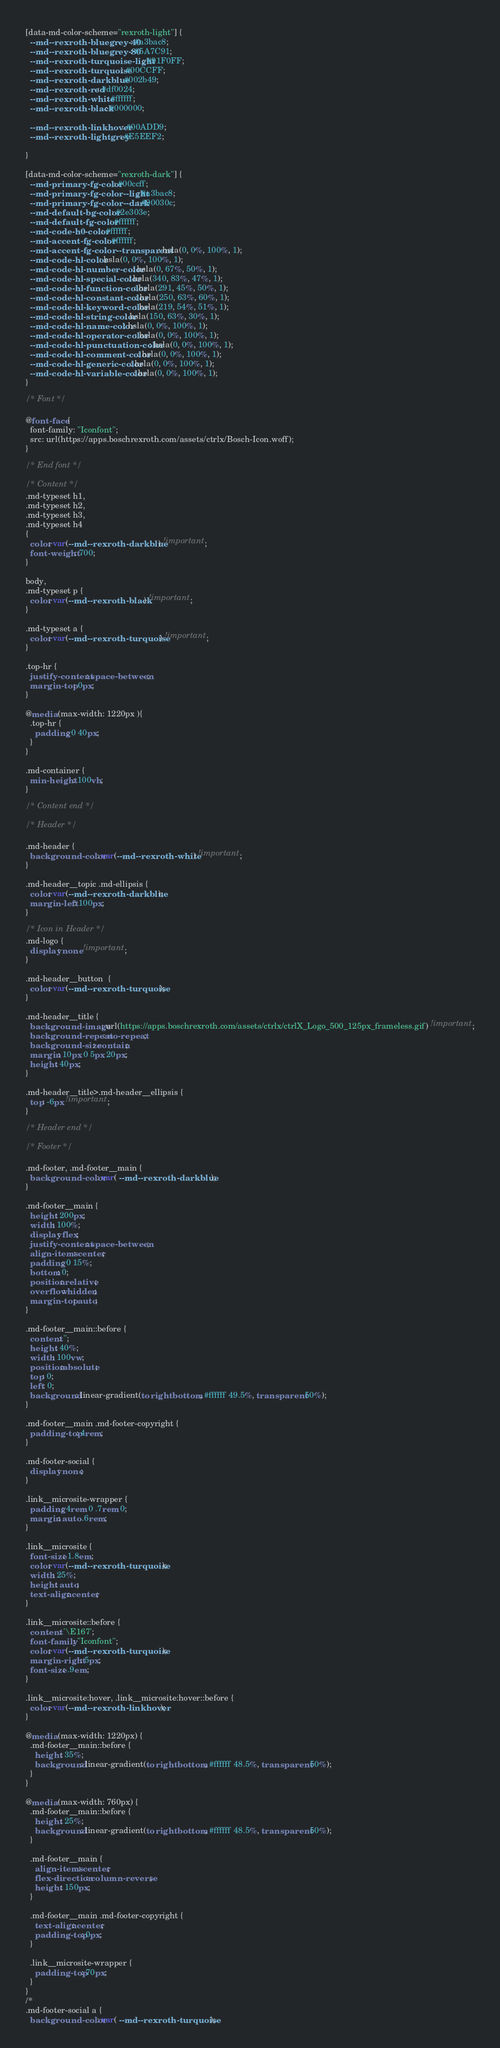Convert code to text. <code><loc_0><loc_0><loc_500><loc_500><_CSS_>[data-md-color-scheme="rexroth-light"] {
  --md--rexroth-bluegrey-40: #a3bac8;
  --md--rexroth-bluegrey-80: #5A7C91;
  --md--rexroth-turquoise-light: #91F0FF;
  --md--rexroth-turquoise: #00CCFF;
  --md--rexroth-darkblue: #002b49;
  --md--rexroth-red: #df0024;
  --md--rexroth-white: #ffffff;
  --md--rexroth-black: #000000;

  --md--rexroth-linkhover: #00ADD9;
  --md--rexroth-lightgrey: #E5EEF2;

}

[data-md-color-scheme="rexroth-dark"] {
  --md-primary-fg-color: #00ccff;
  --md-primary-fg-color--light: #a3bac8;
  --md-primary-fg-color--dark: #90030c;
  --md-default-bg-color: #2e303e;
  --md-default-fg-color: #ffffff;
  --md-code-h0-color: #ffffff;
  --md-accent-fg-color: #ffffff;
  --md-accent-fg-color--transparent: hsla(0, 0%, 100%, 1);
  --md-code-hl-color: hsla(0, 0%, 100%, 1);
  --md-code-hl-number-color: hsla(0, 67%, 50%, 1);
  --md-code-hl-special-color: hsla(340, 83%, 47%, 1);
  --md-code-hl-function-color: hsla(291, 45%, 50%, 1);
  --md-code-hl-constant-color: hsla(250, 63%, 60%, 1);
  --md-code-hl-keyword-color: hsla(219, 54%, 51%, 1);
  --md-code-hl-string-color: hsla(150, 63%, 30%, 1);
  --md-code-hl-name-color: hsla(0, 0%, 100%, 1);
  --md-code-hl-operator-color: hsla(0, 0%, 100%, 1);
  --md-code-hl-punctuation-color: hsla(0, 0%, 100%, 1);
  --md-code-hl-comment-color: hsla(0, 0%, 100%, 1);
  --md-code-hl-generic-color: hsla(0, 0%, 100%, 1);
  --md-code-hl-variable-color: hsla(0, 0%, 100%, 1);
}

/* Font */

@font-face {
  font-family: "Iconfont";
  src: url(https://apps.boschrexroth.com/assets/ctrlx/Bosch-Icon.woff);
}

/* End font */

/* Content */
.md-typeset h1,
.md-typeset h2,
.md-typeset h3,
.md-typeset h4
{
  color: var(--md--rexroth-darkblue) !important;
  font-weight: 700;
}

body,
.md-typeset p {
  color: var(--md--rexroth-black) !important;
}

.md-typeset a {
  color: var(--md--rexroth-turquoise) !important;
}

.top-hr {
  justify-content: space-between;
  margin-top: 0px;
}

@media (max-width: 1220px ){
  .top-hr {
    padding: 0 40px;
  }
}

.md-container {
  min-height: 100vh;
}

/* Content end */

/* Header */

.md-header {
  background-color: var(--md--rexroth-white) !important;
}

.md-header__topic .md-ellipsis {
  color: var(--md--rexroth-darkblue);
  margin-left: 100px;
}

/* Icon in Header */ 
.md-logo {
  display: none !important;
}

.md-header__button  {
  color: var(--md--rexroth-turquoise);
}

.md-header__title {
  background-image: url(https://apps.boschrexroth.com/assets/ctrlx/ctrlX_Logo_500_125px_frameless.gif) !important;
  background-repeat: no-repeat;
  background-size: contain;
  margin: 10px 0 5px 20px;
  height: 40px;
}

.md-header__title>.md-header__ellipsis {
  top: -6px !important;
}

/* Header end */

/* Footer */

.md-footer, .md-footer__main {
  background-color: var( --md--rexroth-darkblue );
}

.md-footer__main {
  height: 200px;
  width: 100%;
  display: flex;
  justify-content: space-between;
  align-items: center;
  padding: 0 15%;
  bottom: 0;
  position: relative;
  overflow: hidden;
  margin-top: auto;
}

.md-footer__main::before {
  content: '';
  height: 40%;
  width: 100vw;
  position:absolute;
  top: 0;
  left: 0;
  background: linear-gradient(to right bottom, #ffffff 49.5%, transparent 50%);
} 

.md-footer__main .md-footer-copyright {
  padding-top: 4rem;
}

.md-footer-social {
  display: none;
}

.link__microsite-wrapper {
  padding: 4rem 0 .7rem 0;
  margin: auto .6rem;
}

.link__microsite {
  font-size: 1.8em;
  color: var(--md--rexroth-turquoise );
  width: 25%;
  height: auto;
  text-align: center;
}

.link__microsite::before {
  content: '\E167';
  font-family: "Iconfont";
  color: var(--md--rexroth-turquoise );
  margin-right: 5px;
  font-size: .9em;
}

.link__microsite:hover, .link__microsite:hover::before {
  color: var(--md--rexroth-linkhover);
}

@media (max-width: 1220px) {
  .md-footer__main::before {
    height: 35%;
    background: linear-gradient(to right bottom, #ffffff 48.5%, transparent 50%);
  }
}

@media (max-width: 760px) {
  .md-footer__main::before {
    height: 25%;
    background: linear-gradient(to right bottom, #ffffff 48.5%, transparent 50%);
  }

  .md-footer__main {
    align-items: center;
    flex-direction: column-reverse;
    height: 150px;
  }

  .md-footer__main .md-footer-copyright {
    text-align: center;
    padding-top: 0px;
  }

  .link__microsite-wrapper {
    padding-top: 70px;
  }
}
/*
.md-footer-social a {
  background-color: var( --md--rexroth-turquoise);</code> 